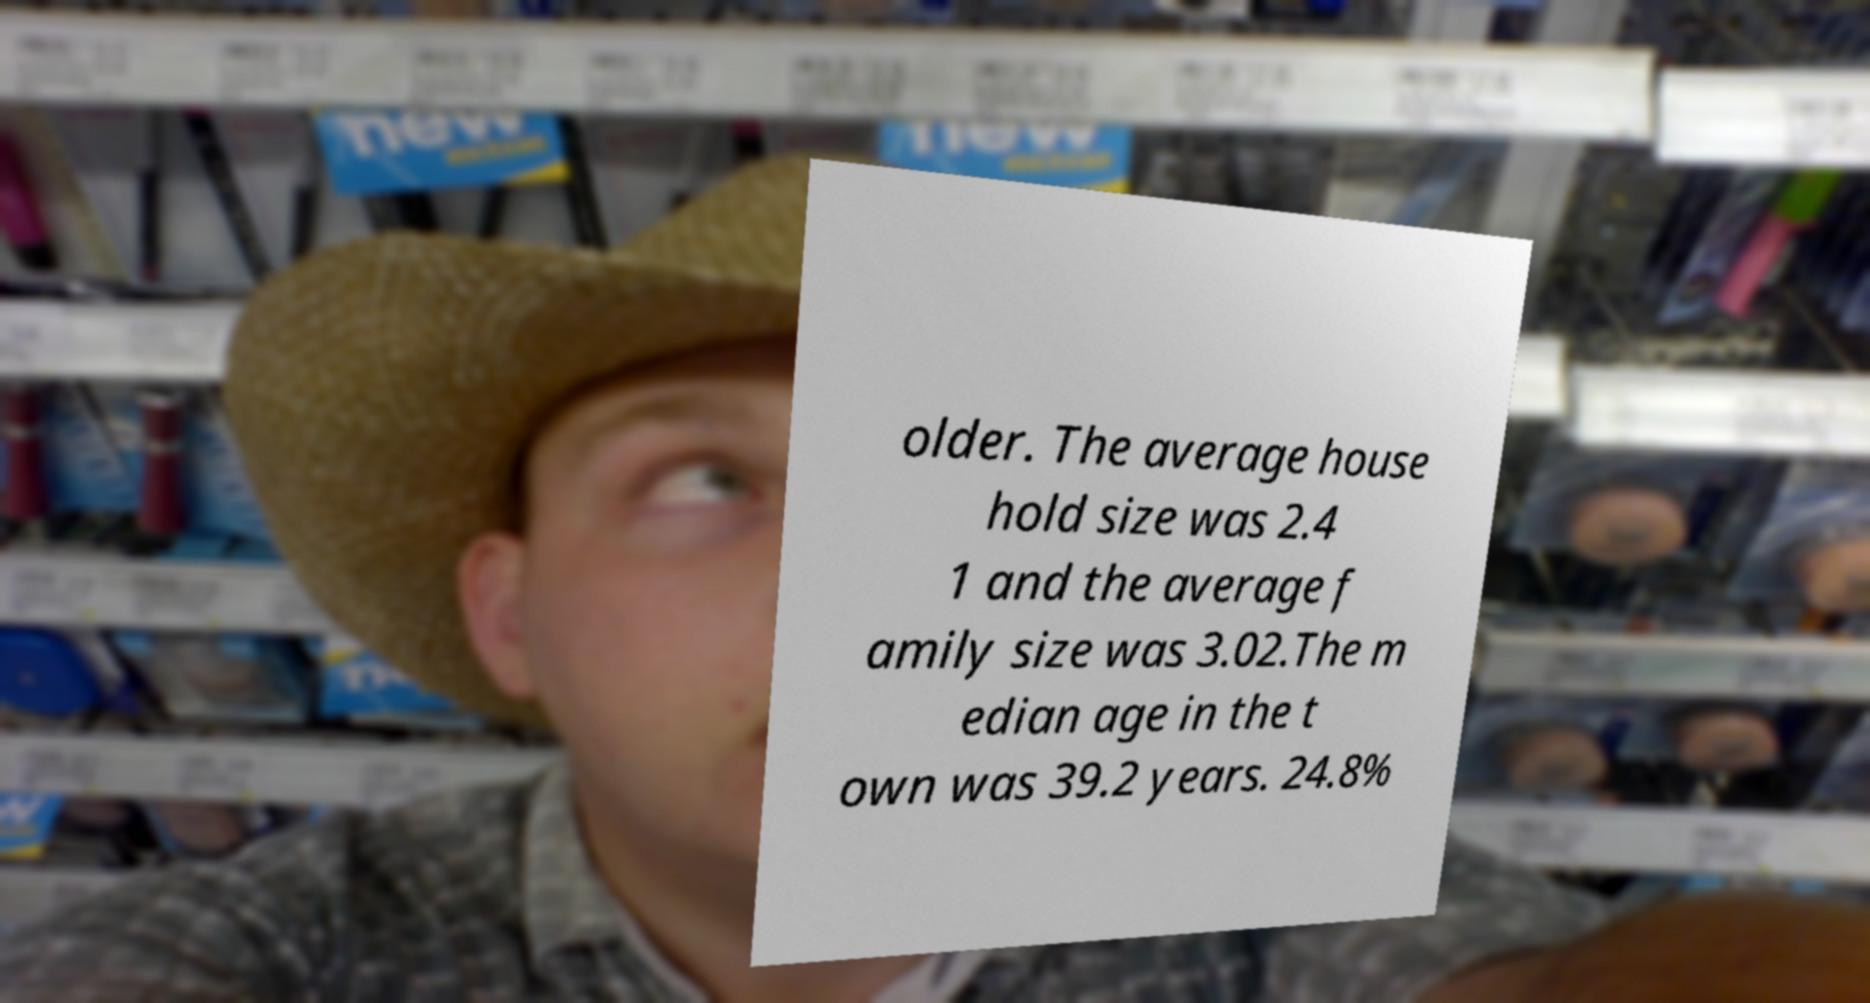Please read and relay the text visible in this image. What does it say? older. The average house hold size was 2.4 1 and the average f amily size was 3.02.The m edian age in the t own was 39.2 years. 24.8% 